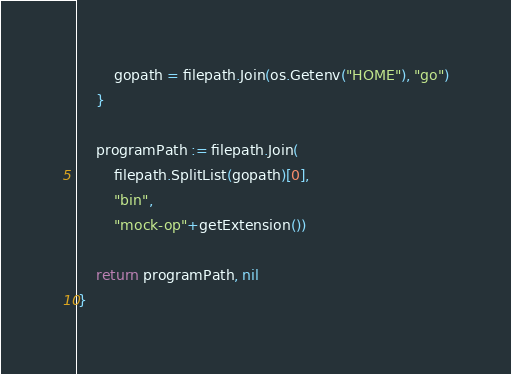Convert code to text. <code><loc_0><loc_0><loc_500><loc_500><_Go_>		gopath = filepath.Join(os.Getenv("HOME"), "go")
	}

	programPath := filepath.Join(
		filepath.SplitList(gopath)[0],
		"bin",
		"mock-op"+getExtension())

	return programPath, nil
}
</code> 